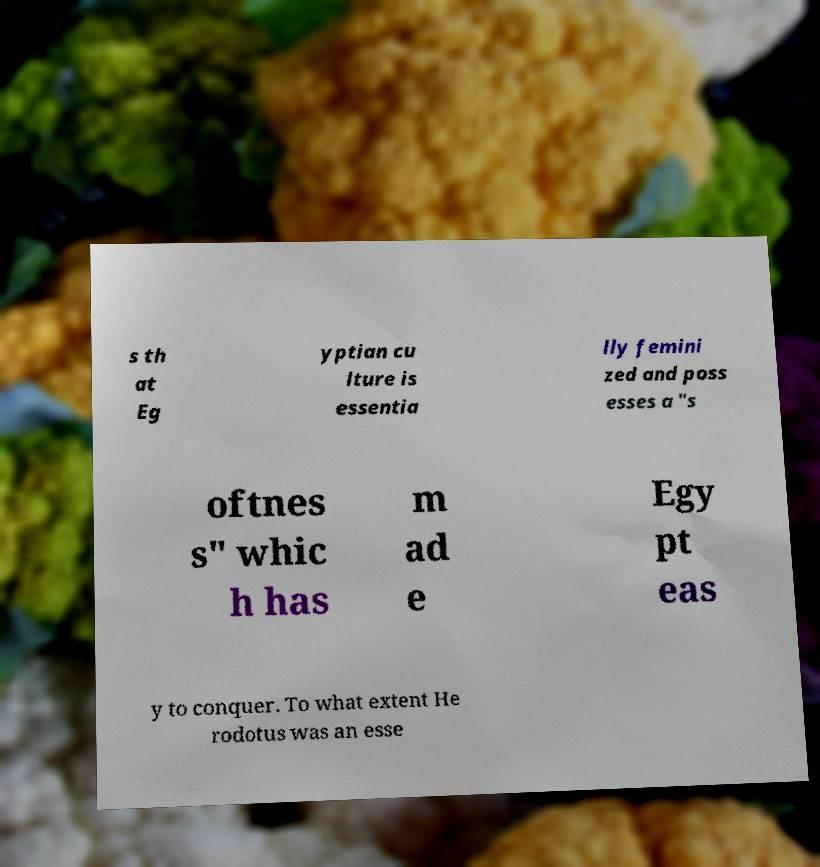Could you assist in decoding the text presented in this image and type it out clearly? s th at Eg yptian cu lture is essentia lly femini zed and poss esses a "s oftnes s" whic h has m ad e Egy pt eas y to conquer. To what extent He rodotus was an esse 